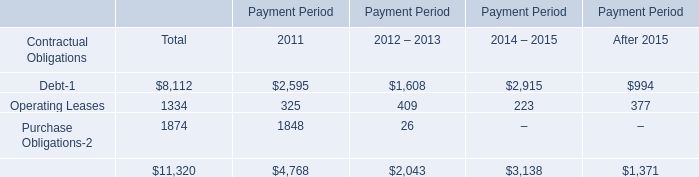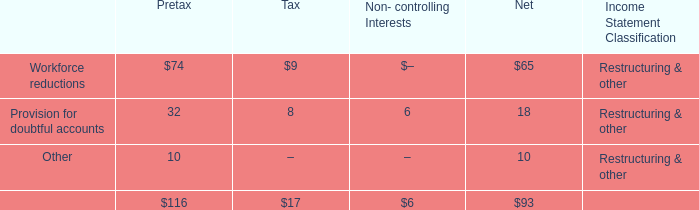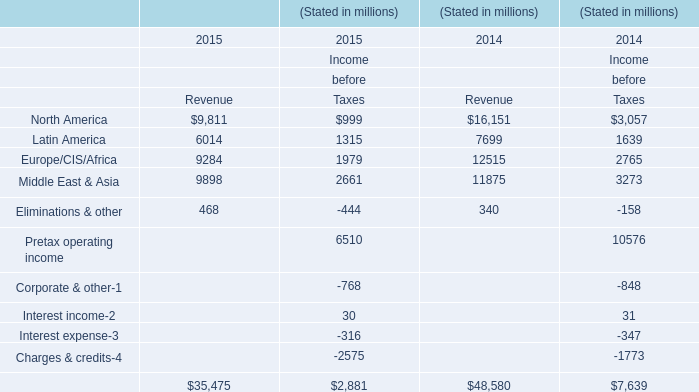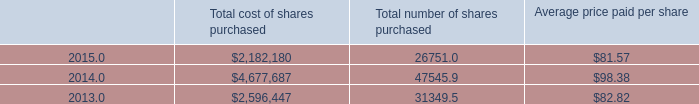Which element for Revenue makes up more than 20 % of the total in 2015? 
Answer: North America, Europe/CIS/Africa,Middle East & Asia. 